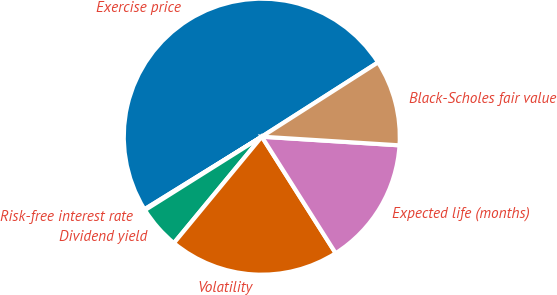Convert chart to OTSL. <chart><loc_0><loc_0><loc_500><loc_500><pie_chart><fcel>Exercise price<fcel>Risk-free interest rate<fcel>Dividend yield<fcel>Volatility<fcel>Expected life (months)<fcel>Black-Scholes fair value<nl><fcel>49.77%<fcel>0.11%<fcel>5.08%<fcel>19.98%<fcel>15.01%<fcel>10.05%<nl></chart> 